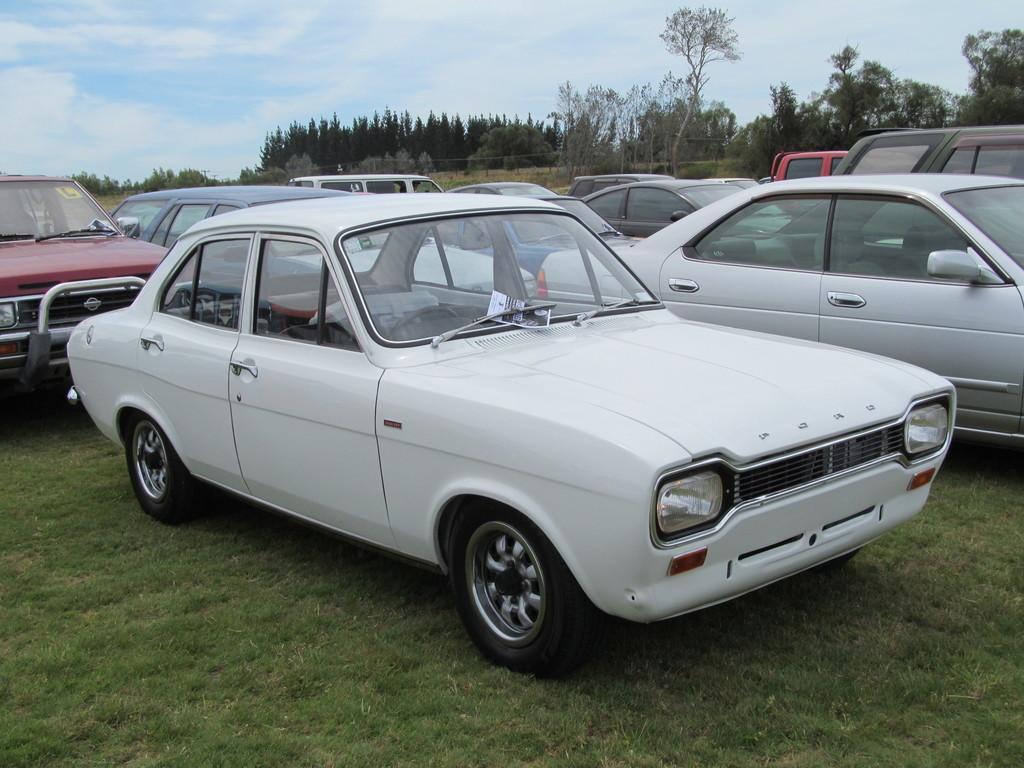Please provide a concise description of this image. In this image, we can see vehicles on the ground and in the background, there are trees. At the top, there are clouds in the sky. 